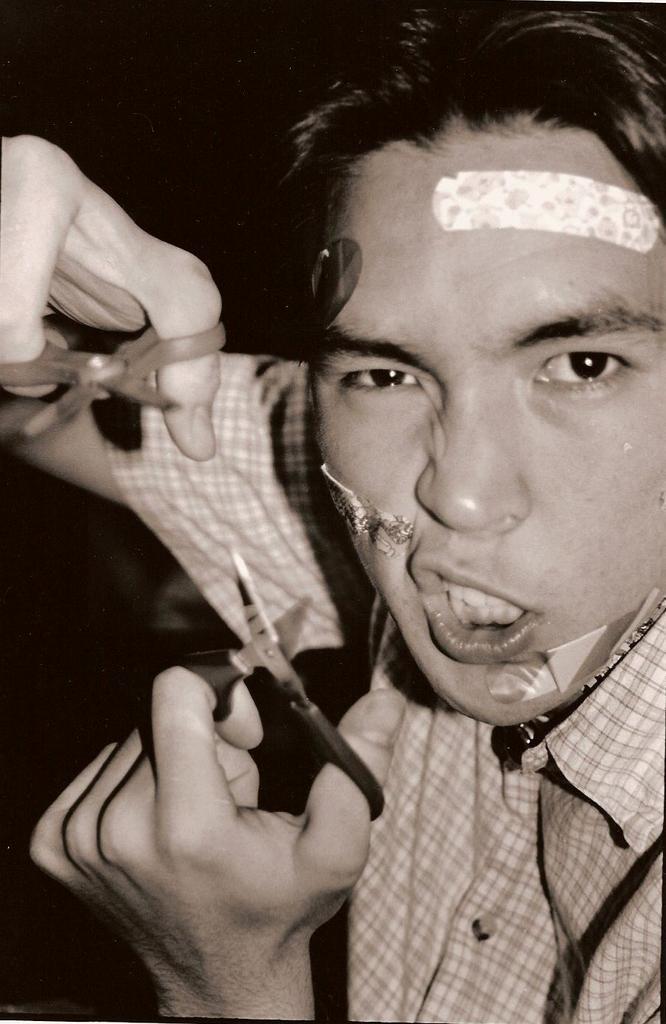Describe this image in one or two sentences. In this picture we can see a man holding scissors with his hands and in the background it is dark. 